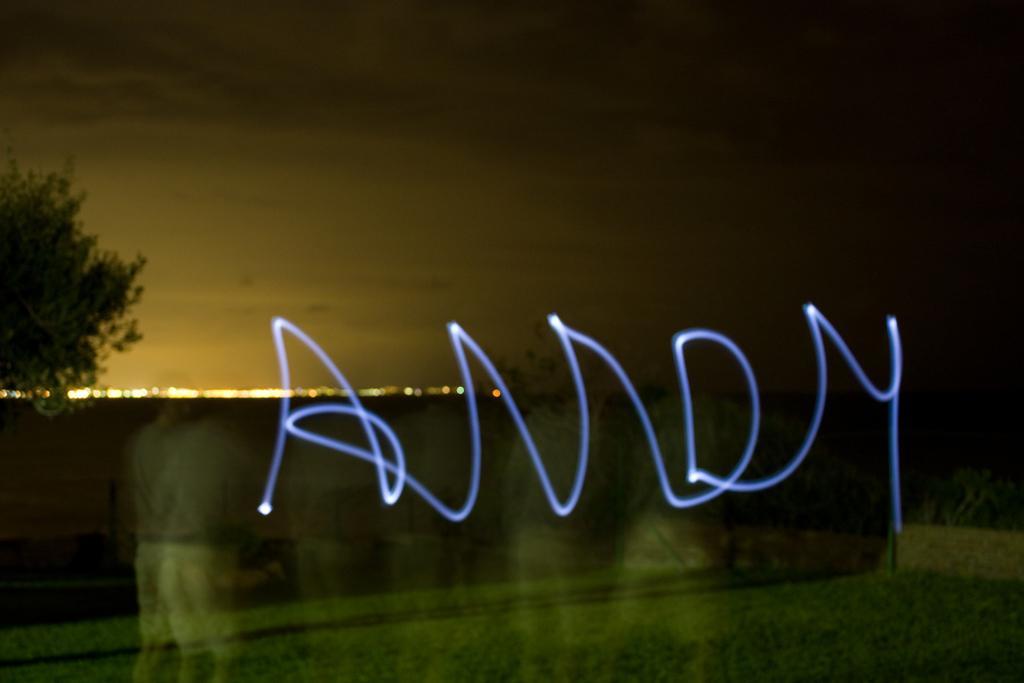Could you give a brief overview of what you see in this image? In this picture we can observe a glass. There is a tree on the left side. In the background we can observe some lights and a sky. 